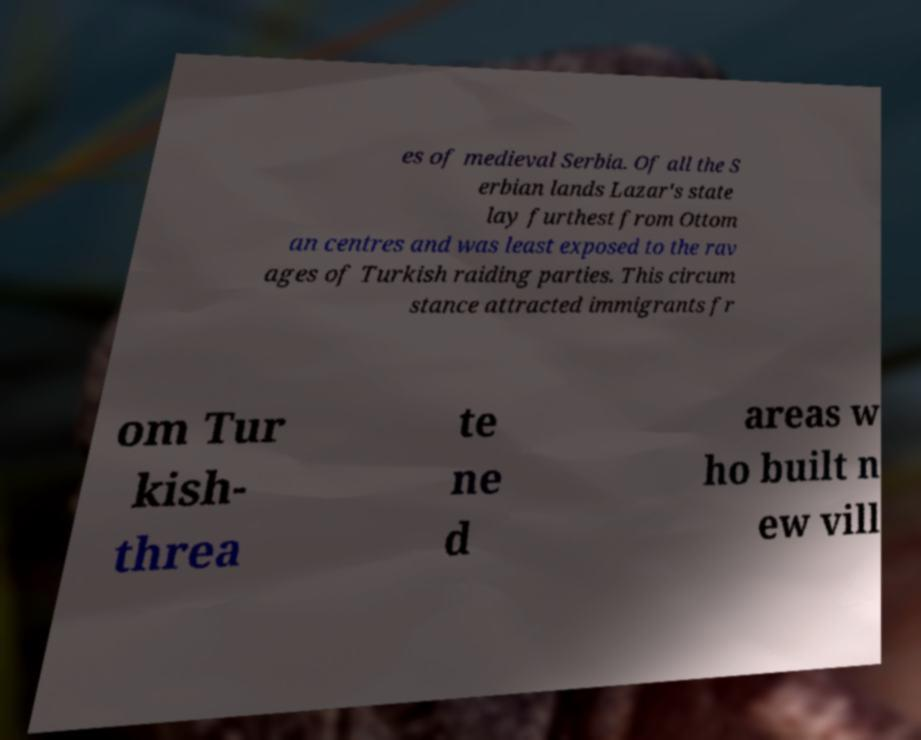Can you read and provide the text displayed in the image?This photo seems to have some interesting text. Can you extract and type it out for me? es of medieval Serbia. Of all the S erbian lands Lazar's state lay furthest from Ottom an centres and was least exposed to the rav ages of Turkish raiding parties. This circum stance attracted immigrants fr om Tur kish- threa te ne d areas w ho built n ew vill 